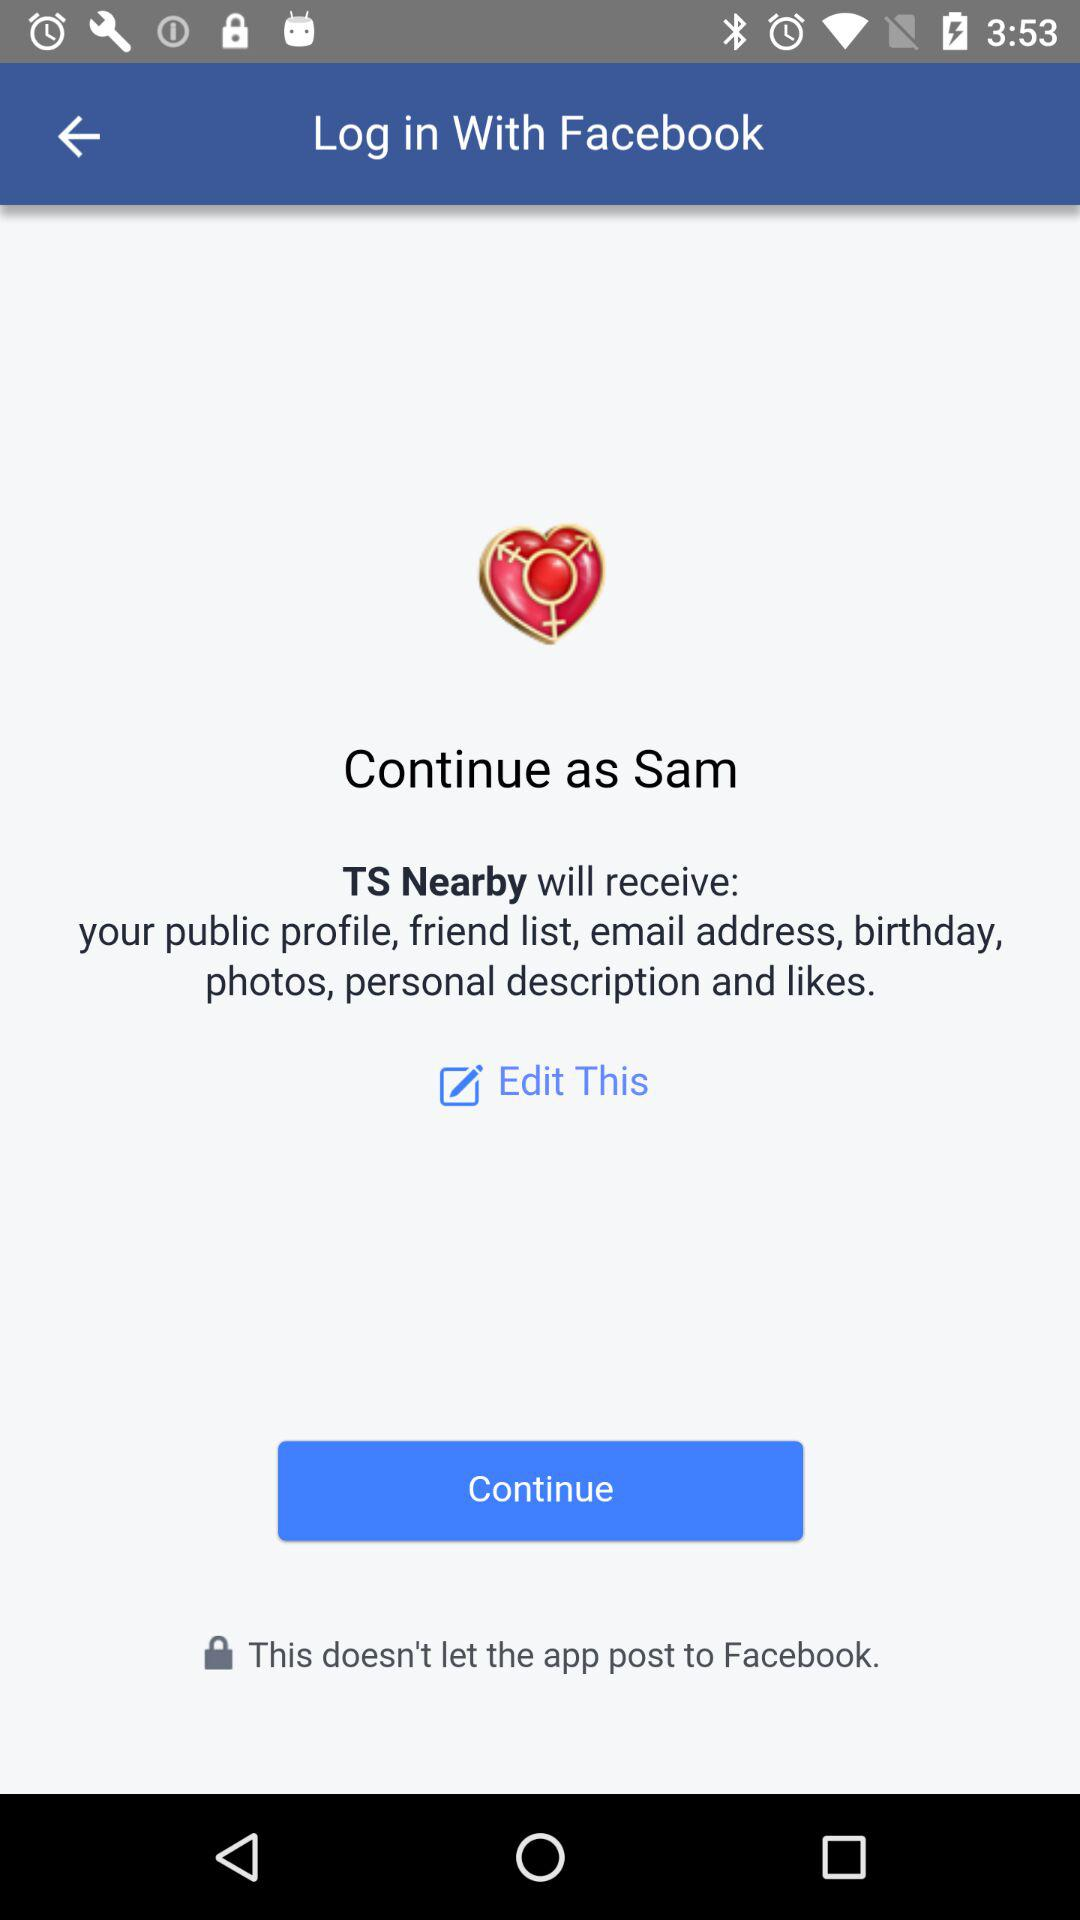What application is asking for permission? The application asking for permission is "TS Nearby". 